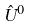Convert formula to latex. <formula><loc_0><loc_0><loc_500><loc_500>\hat { U } ^ { 0 }</formula> 